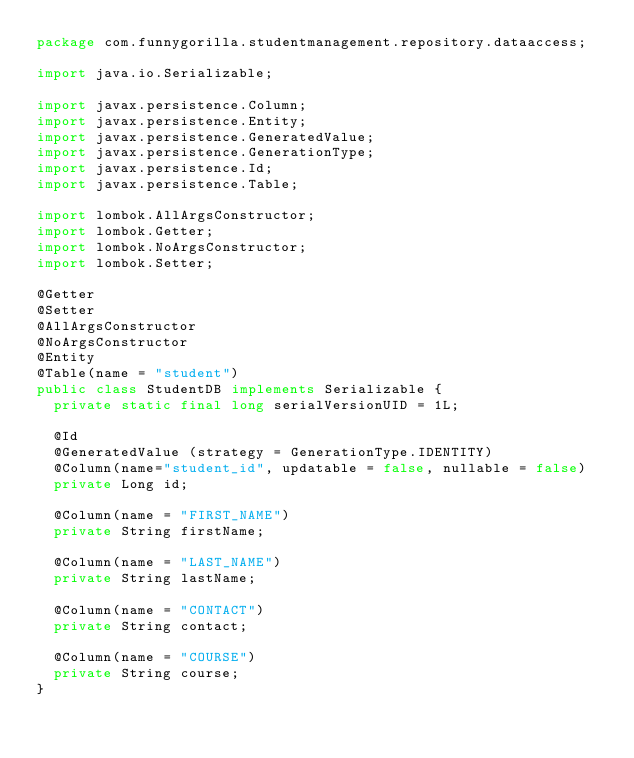Convert code to text. <code><loc_0><loc_0><loc_500><loc_500><_Java_>package com.funnygorilla.studentmanagement.repository.dataaccess;

import java.io.Serializable;

import javax.persistence.Column;
import javax.persistence.Entity;
import javax.persistence.GeneratedValue;
import javax.persistence.GenerationType;
import javax.persistence.Id;
import javax.persistence.Table;

import lombok.AllArgsConstructor;
import lombok.Getter;
import lombok.NoArgsConstructor;
import lombok.Setter;

@Getter
@Setter
@AllArgsConstructor
@NoArgsConstructor
@Entity  
@Table(name = "student")
public class StudentDB implements Serializable {	
	private static final long serialVersionUID = 1L;
	
	@Id 
	@GeneratedValue (strategy = GenerationType.IDENTITY)
	@Column(name="student_id", updatable = false, nullable = false)
	private Long id;
	
	@Column(name = "FIRST_NAME")
	private String firstName;
	
	@Column(name = "LAST_NAME")
	private String lastName;
	
	@Column(name = "CONTACT")
	private String contact;
	
	@Column(name = "COURSE")
	private String course;
}
</code> 